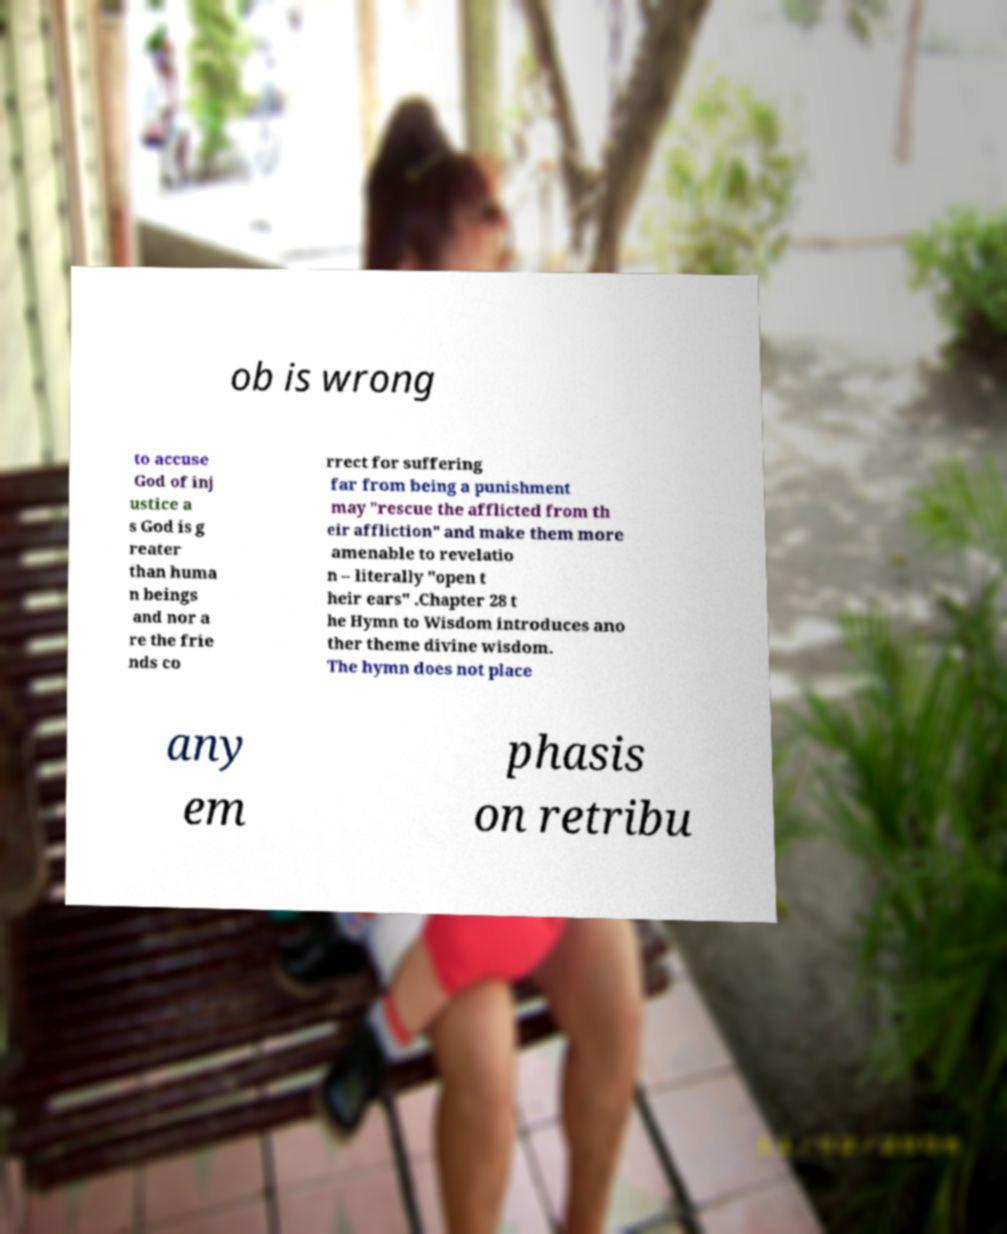Can you accurately transcribe the text from the provided image for me? ob is wrong to accuse God of inj ustice a s God is g reater than huma n beings and nor a re the frie nds co rrect for suffering far from being a punishment may "rescue the afflicted from th eir affliction" and make them more amenable to revelatio n – literally "open t heir ears" .Chapter 28 t he Hymn to Wisdom introduces ano ther theme divine wisdom. The hymn does not place any em phasis on retribu 